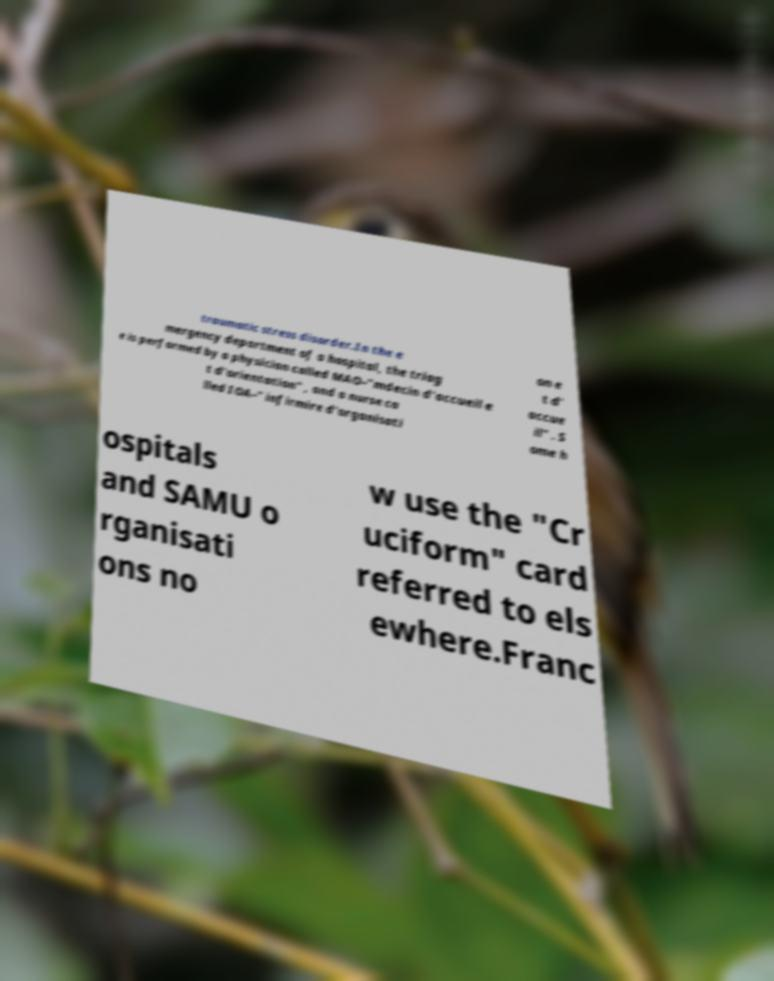Can you read and provide the text displayed in the image?This photo seems to have some interesting text. Can you extract and type it out for me? traumatic stress disorder.In the e mergency department of a hospital, the triag e is performed by a physician called MAO–"mdecin d'accueil e t d'orientation" , and a nurse ca lled IOA–" infirmire d'organisati on e t d' accue il" . S ome h ospitals and SAMU o rganisati ons no w use the "Cr uciform" card referred to els ewhere.Franc 